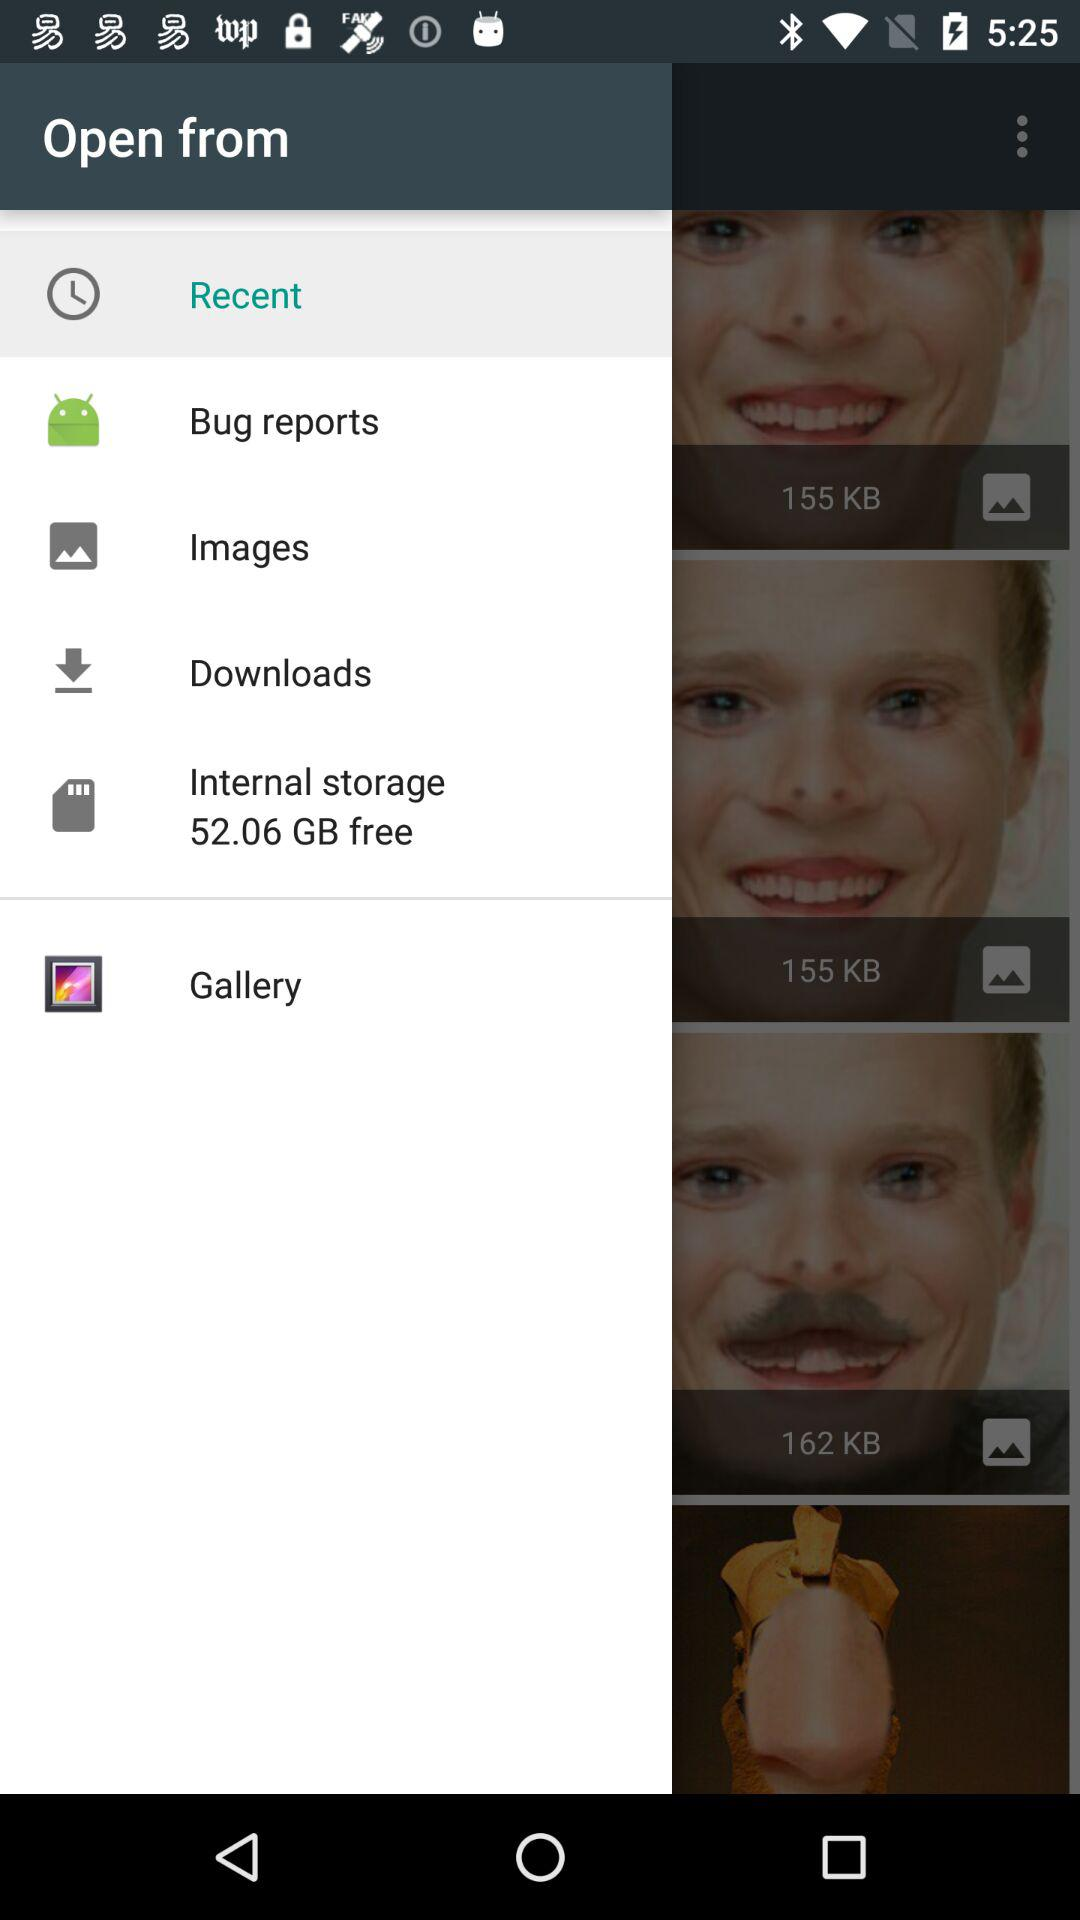How much internal storage is free? There are 52.06 GB free in the internal storage. 